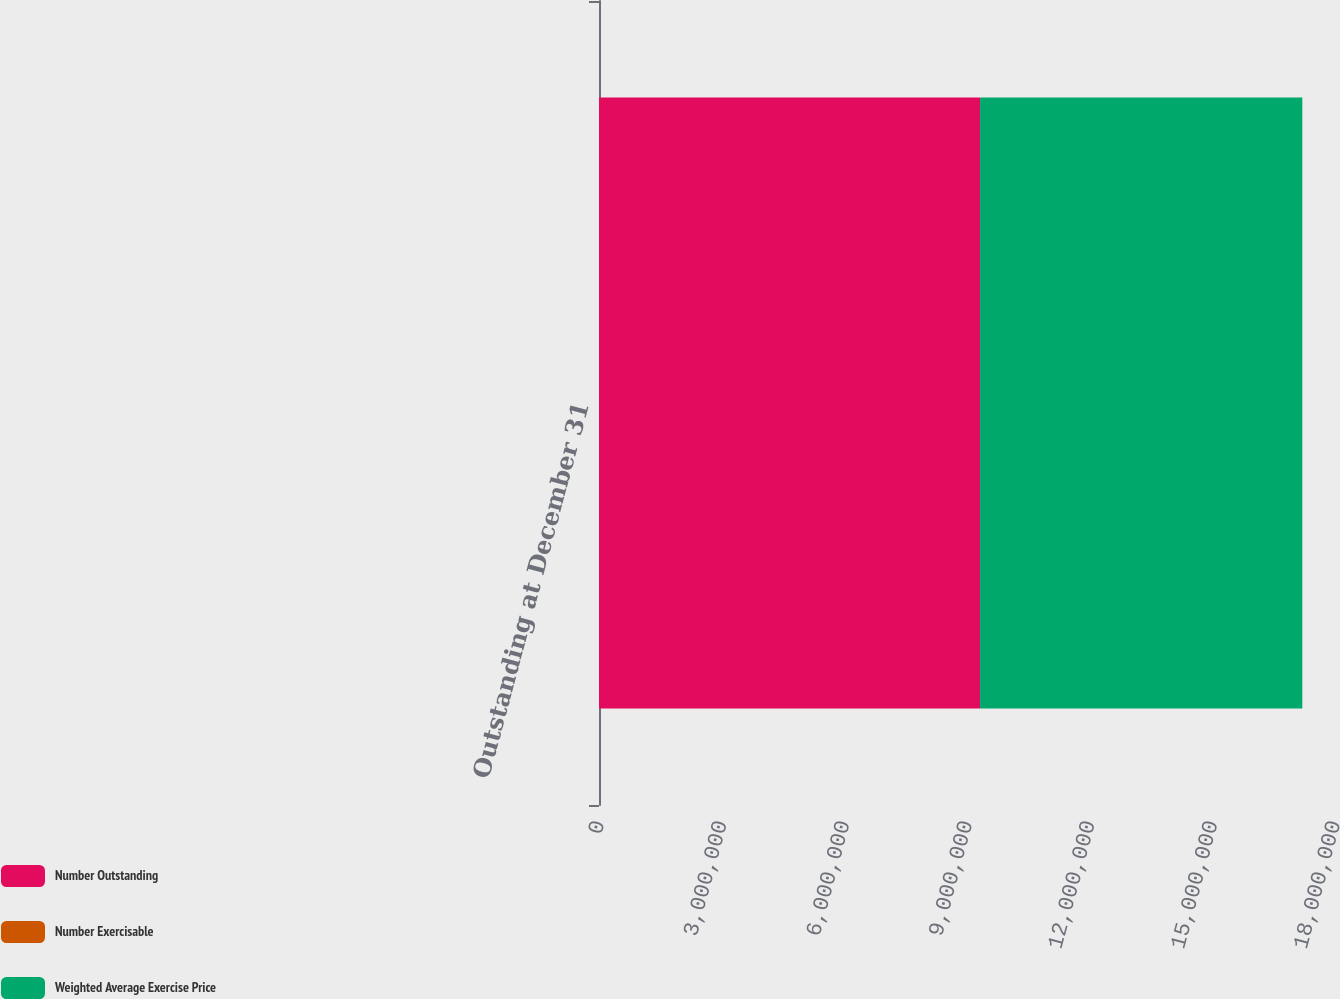Convert chart. <chart><loc_0><loc_0><loc_500><loc_500><stacked_bar_chart><ecel><fcel>Outstanding at December 31<nl><fcel>Number Outstanding<fcel>9.31964e+06<nl><fcel>Number Exercisable<fcel>19.21<nl><fcel>Weighted Average Exercise Price<fcel>7.88116e+06<nl></chart> 